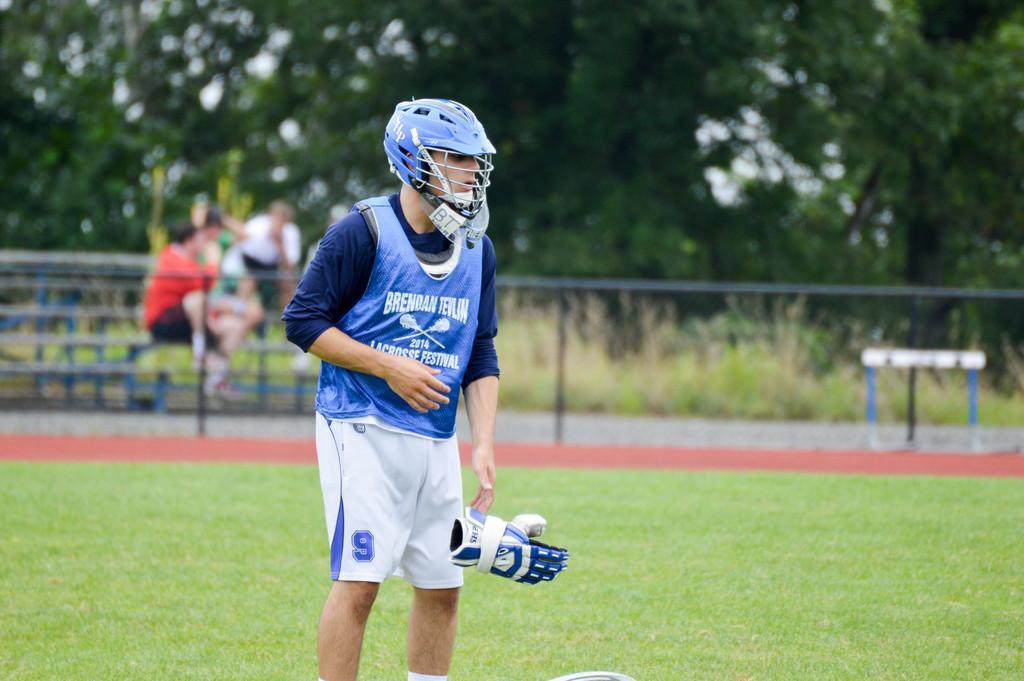Can you describe this image briefly? In this picture we can see a man with the helmet and the man is holding a glove. Behind the man there are iron grilles and some people are sitting. Behind the people there are trees. 